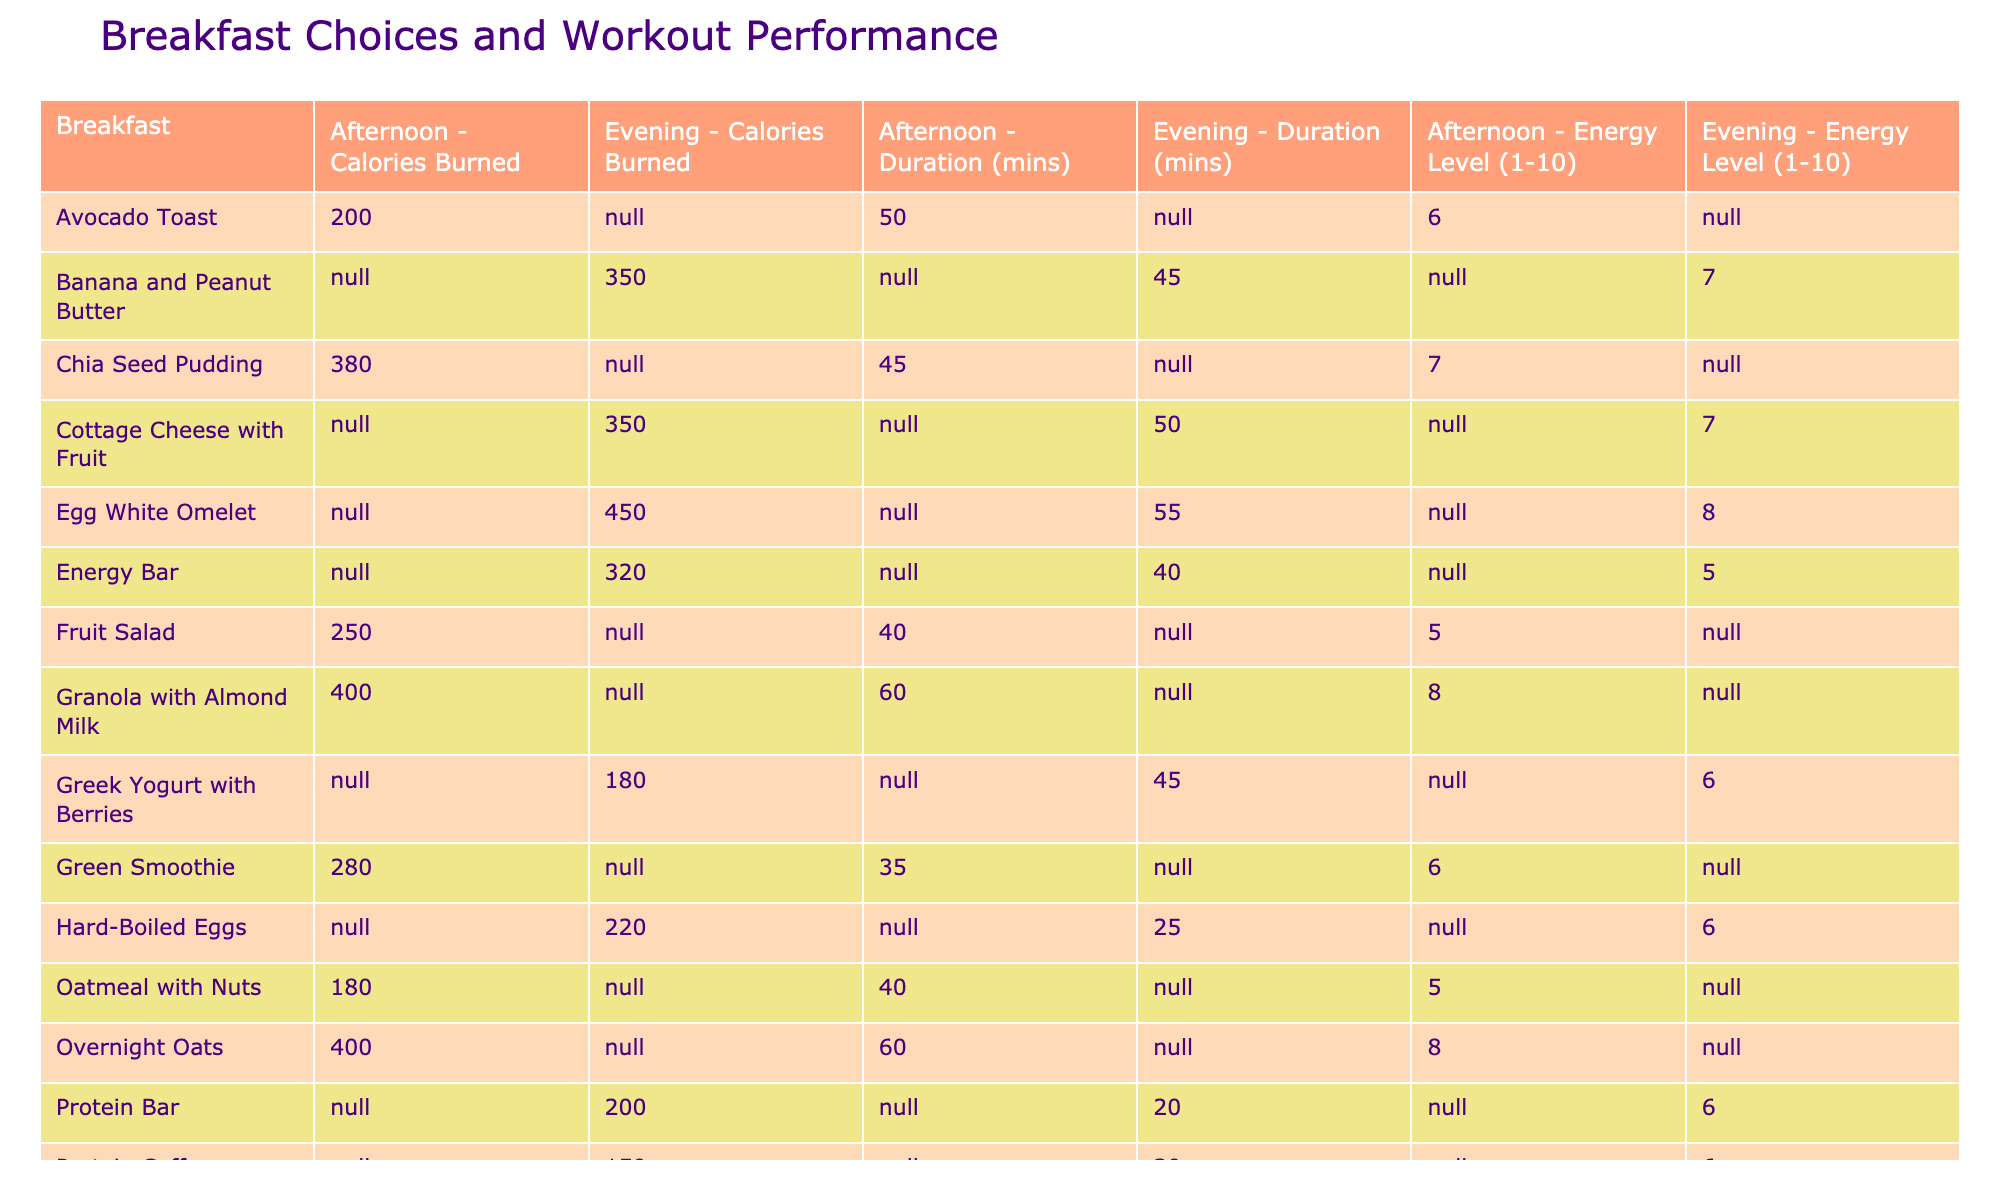What is the highest energy level recorded for breakfast choices? By scanning through the Energy Level column, the highest value recorded is 8, which appears for the Egg White Omelet and the Overnight Oats.
Answer: 8 Which breakfast leads to the longest average workout duration? The average workout duration for each breakfast is calculated, and the longest duration of 60 mins is for both Overnight Oats and Granola with Almond Milk.
Answer: 60 mins Is a Protein Shake associated with higher calories burned compared to an Energy Bar? The Protein Shake has a calories burned value of 300, while the Energy Bar has 320, indicating that the Energy Bar has a slightly higher calorie burn.
Answer: No How does the average energy level compare between breakfasts taken in the Afternoon and Evening? The average energy level for Afternoon breakfasts is calculated: (7 + 8 + 6 + 7 + 5 + 7 + 5) = 45/7 ≈ 6.43. For Evening breakfasts: (6 + 7 + 8 + 5 + 6) = 32/5 = 6.4. The values are quite similar, with Afternoon slightly higher.
Answer: Afternoon is higher Which breakfast has the highest calories burned during workouts, and what is that value? Looking at the Calories Burned column, the Egg White Omelet shows the highest value of 450 calories burned.
Answer: 450 calories Are there any breakfasts that resulted in a fatigue rating (energy level) of 5 or lower? Yes, the Energy Bar, Tai Chi's Oatmeal with Nuts, and Fruit Salad are the only breakfasts that resulted in an energy level of 5 or lower.
Answer: Yes What are the average calories burned for breakfast choices with a preparation time of 40 minutes or less? The breakfasts with a duration of 40 minutes or less include Protein Shake, Smoothie Bowl, and Jump Rope Protein Bar, and their calories burned are 300, 280, and 200, respectively. The average is (300 + 280 + 200) / 3 = 260.
Answer: 260 calories Which two breakfasts have matching energy levels and what is that level? The Protein Pancakes and Whole Grain Toast with Hummus both have an energy level of 7.
Answer: 7 